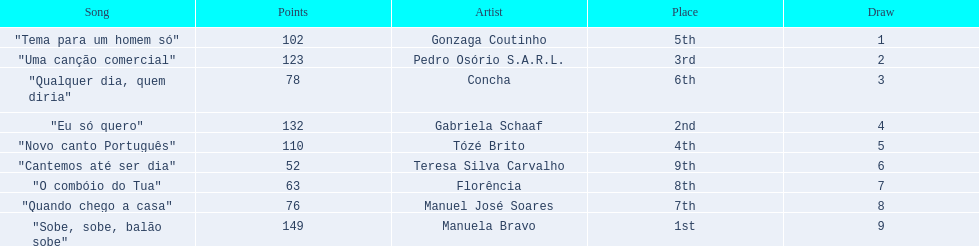Is there a song called eu so quero in the table? "Eu só quero". Who sang that song? Gabriela Schaaf. 